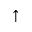<formula> <loc_0><loc_0><loc_500><loc_500>\uparrow</formula> 